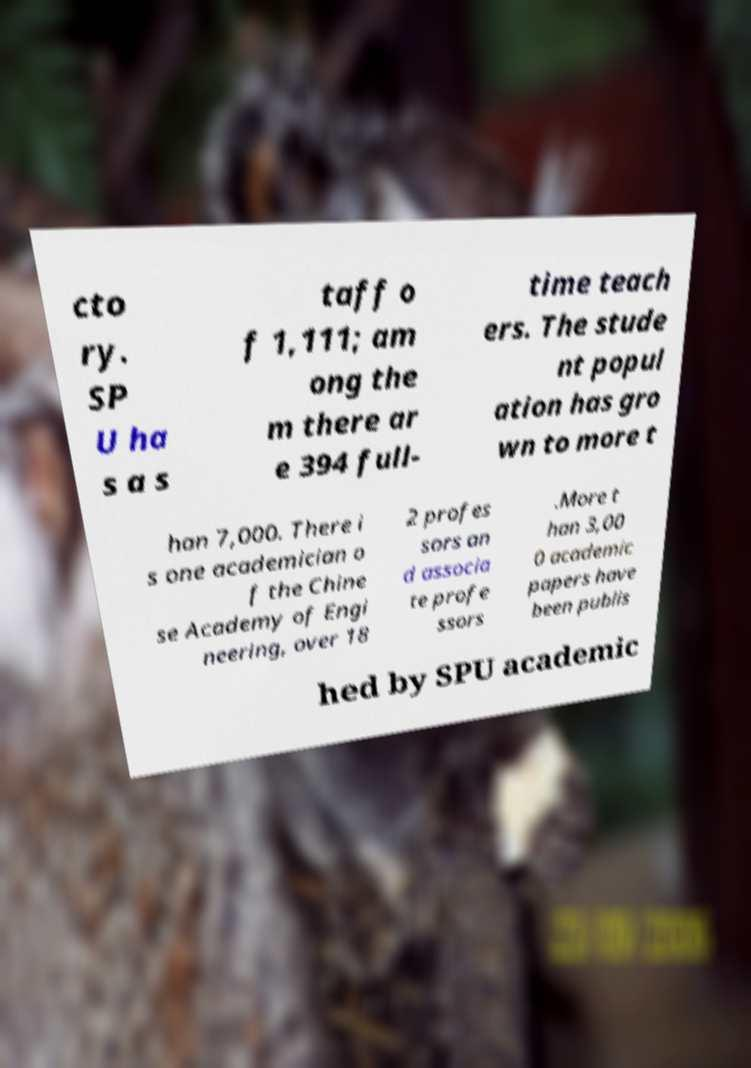Could you extract and type out the text from this image? cto ry. SP U ha s a s taff o f 1,111; am ong the m there ar e 394 full- time teach ers. The stude nt popul ation has gro wn to more t han 7,000. There i s one academician o f the Chine se Academy of Engi neering, over 18 2 profes sors an d associa te profe ssors .More t han 3,00 0 academic papers have been publis hed by SPU academic 